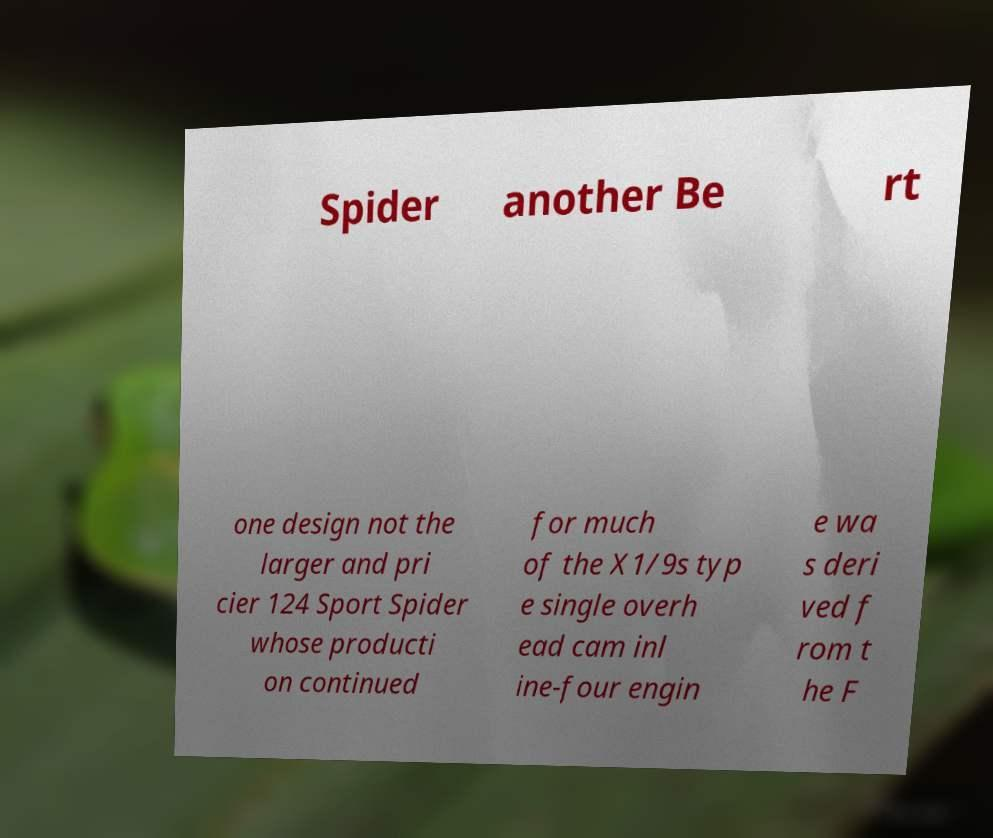What messages or text are displayed in this image? I need them in a readable, typed format. Spider another Be rt one design not the larger and pri cier 124 Sport Spider whose producti on continued for much of the X1/9s typ e single overh ead cam inl ine-four engin e wa s deri ved f rom t he F 